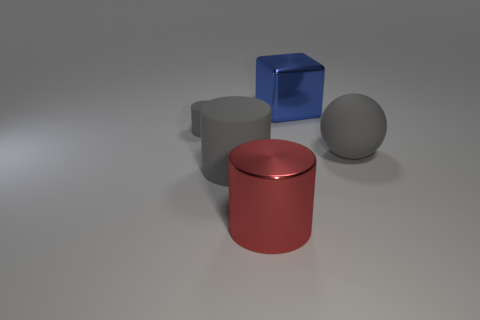Subtract all big cylinders. How many cylinders are left? 1 Add 4 large purple matte cylinders. How many objects exist? 9 Subtract 1 blocks. How many blocks are left? 0 Add 2 small gray matte things. How many small gray matte things exist? 3 Subtract all gray cylinders. How many cylinders are left? 1 Subtract 2 gray cylinders. How many objects are left? 3 Subtract all spheres. How many objects are left? 4 Subtract all yellow cylinders. Subtract all blue blocks. How many cylinders are left? 3 Subtract all blue cubes. How many red cylinders are left? 1 Subtract all large metal cylinders. Subtract all big metal cylinders. How many objects are left? 3 